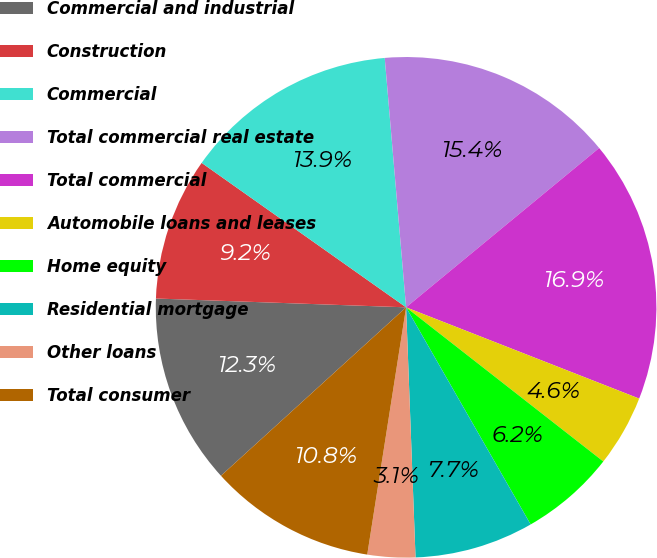Convert chart to OTSL. <chart><loc_0><loc_0><loc_500><loc_500><pie_chart><fcel>Commercial and industrial<fcel>Construction<fcel>Commercial<fcel>Total commercial real estate<fcel>Total commercial<fcel>Automobile loans and leases<fcel>Home equity<fcel>Residential mortgage<fcel>Other loans<fcel>Total consumer<nl><fcel>12.31%<fcel>9.23%<fcel>13.85%<fcel>15.38%<fcel>16.92%<fcel>4.62%<fcel>6.15%<fcel>7.69%<fcel>3.08%<fcel>10.77%<nl></chart> 